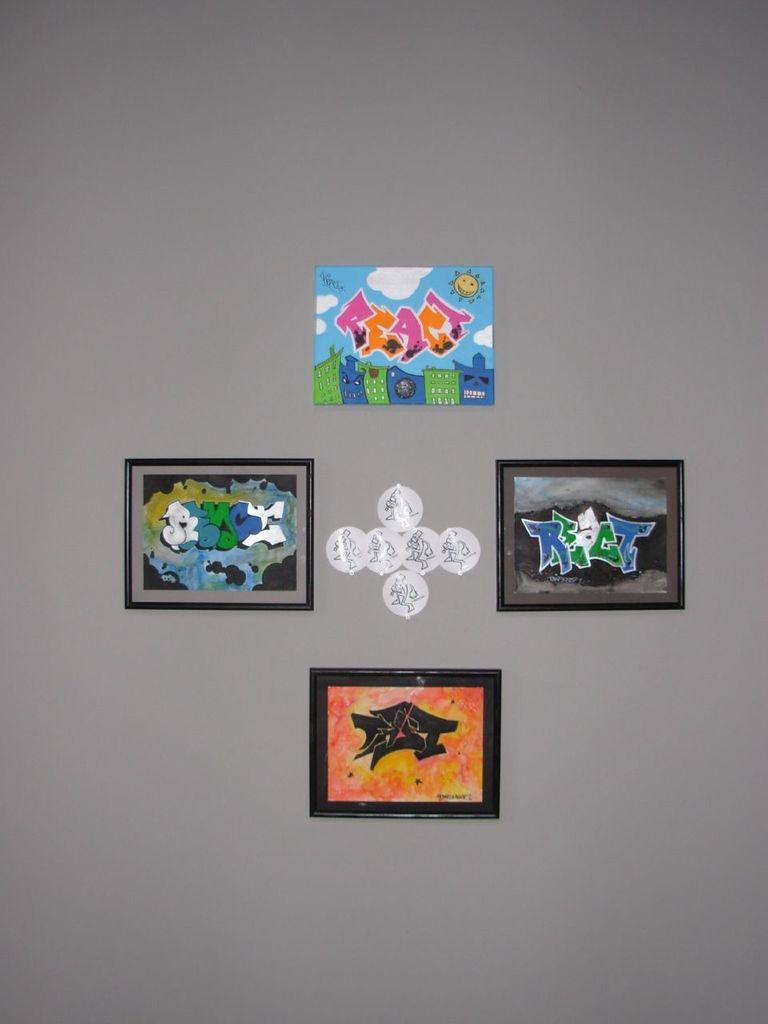What can be seen in the image? There are frames in the image. Can you describe the objects attached to the grey surface? There are white color objects attached to a grey color surface in the image. What type of hand is holding the frames in the image? There is no hand present in the image; it only shows frames and white objects attached to a grey surface. 